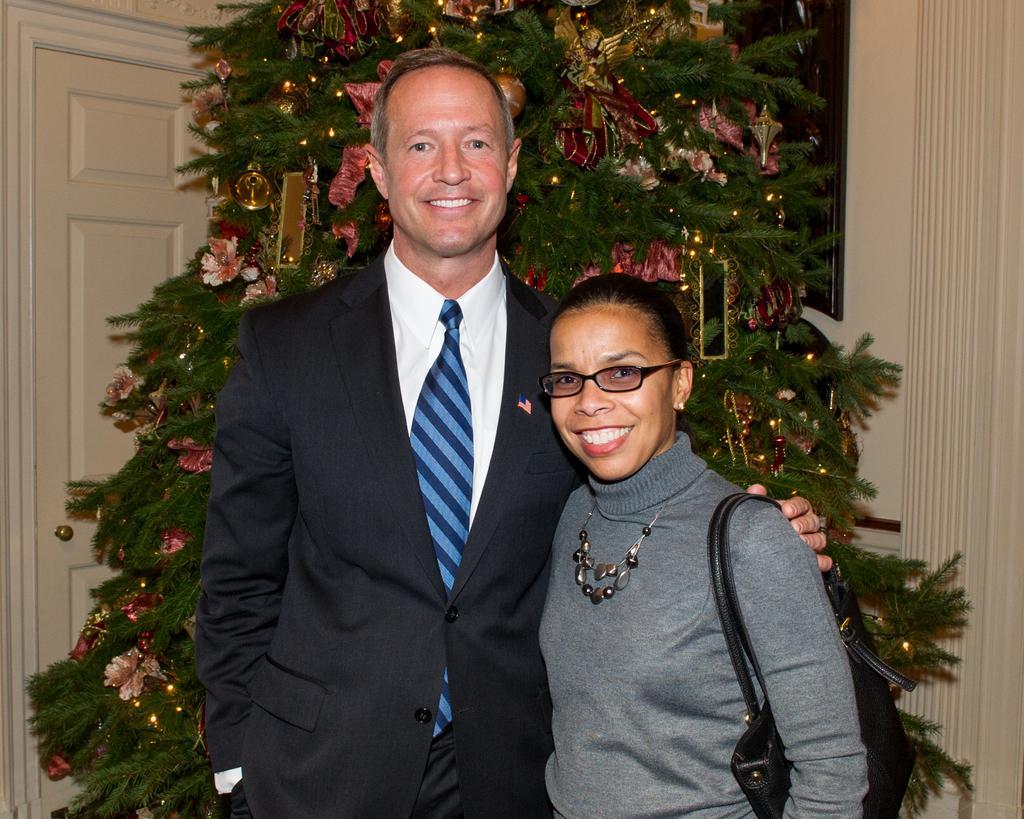How would you summarize this image in a sentence or two? In this image there is a person wearing a blazer and tie. Beside him there is a woman carrying a bag. She is wearing spectacles. Behind them there is a Christmas tree having few decorative items on it. Background there is a wall having a door. 